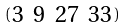Convert formula to latex. <formula><loc_0><loc_0><loc_500><loc_500>\begin{psmallmatrix} 3 & 9 & 2 7 & 3 3 \end{psmallmatrix}</formula> 